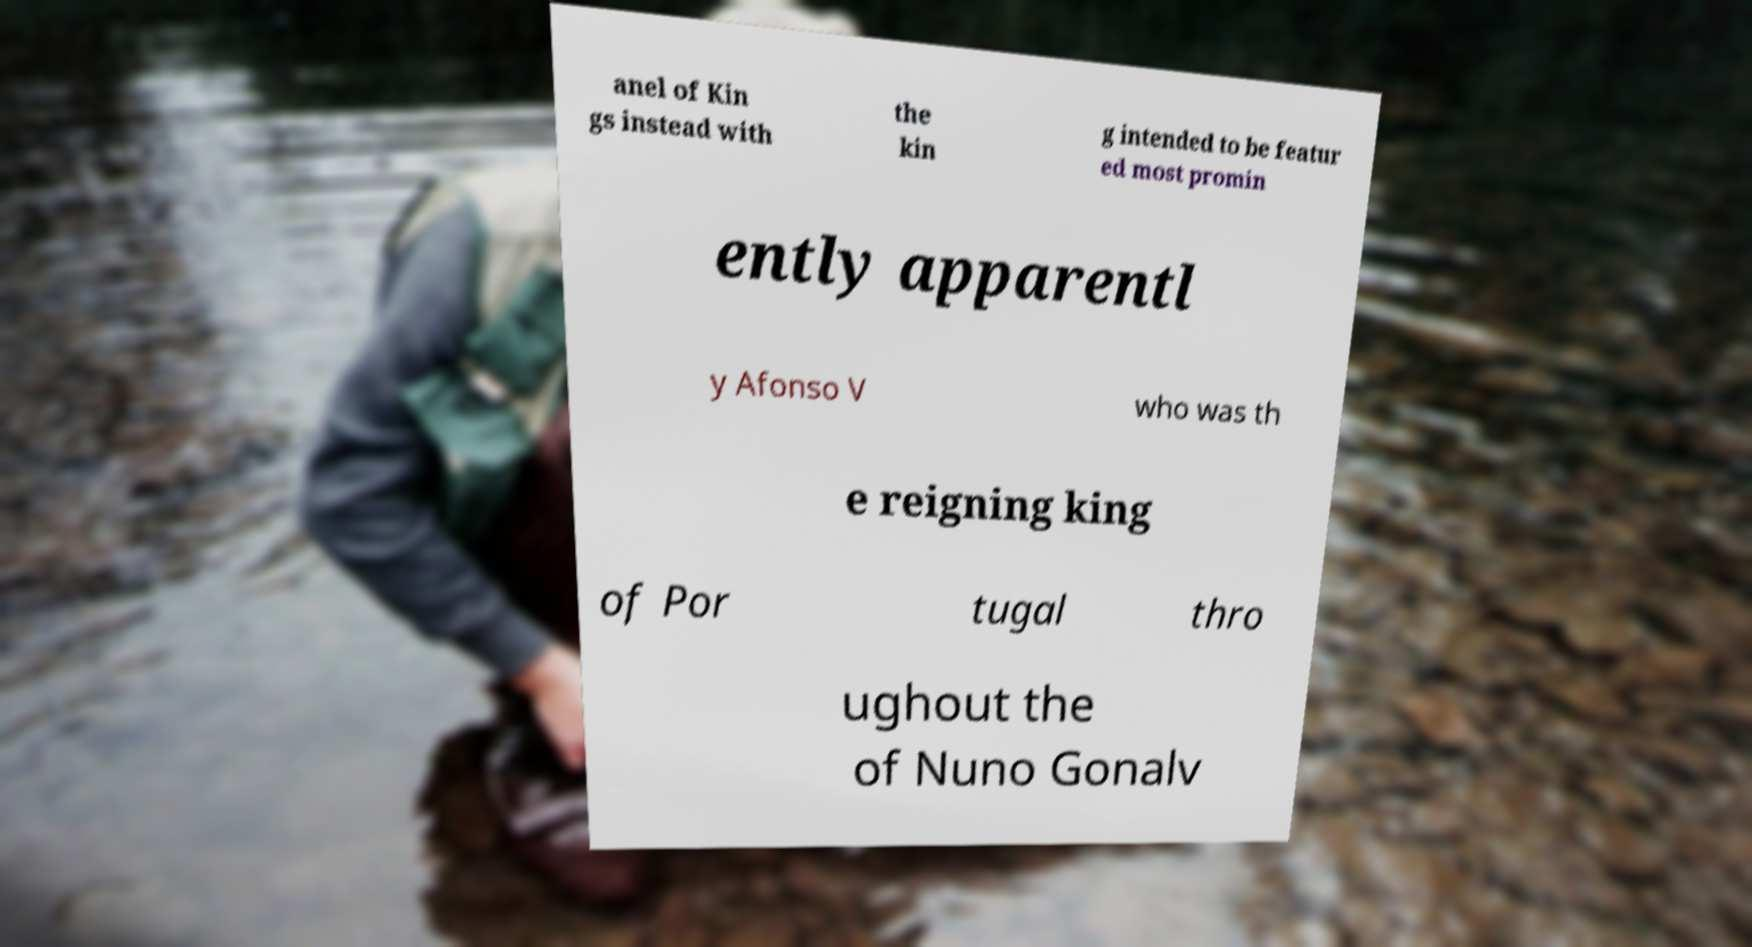Can you read and provide the text displayed in the image?This photo seems to have some interesting text. Can you extract and type it out for me? anel of Kin gs instead with the kin g intended to be featur ed most promin ently apparentl y Afonso V who was th e reigning king of Por tugal thro ughout the of Nuno Gonalv 